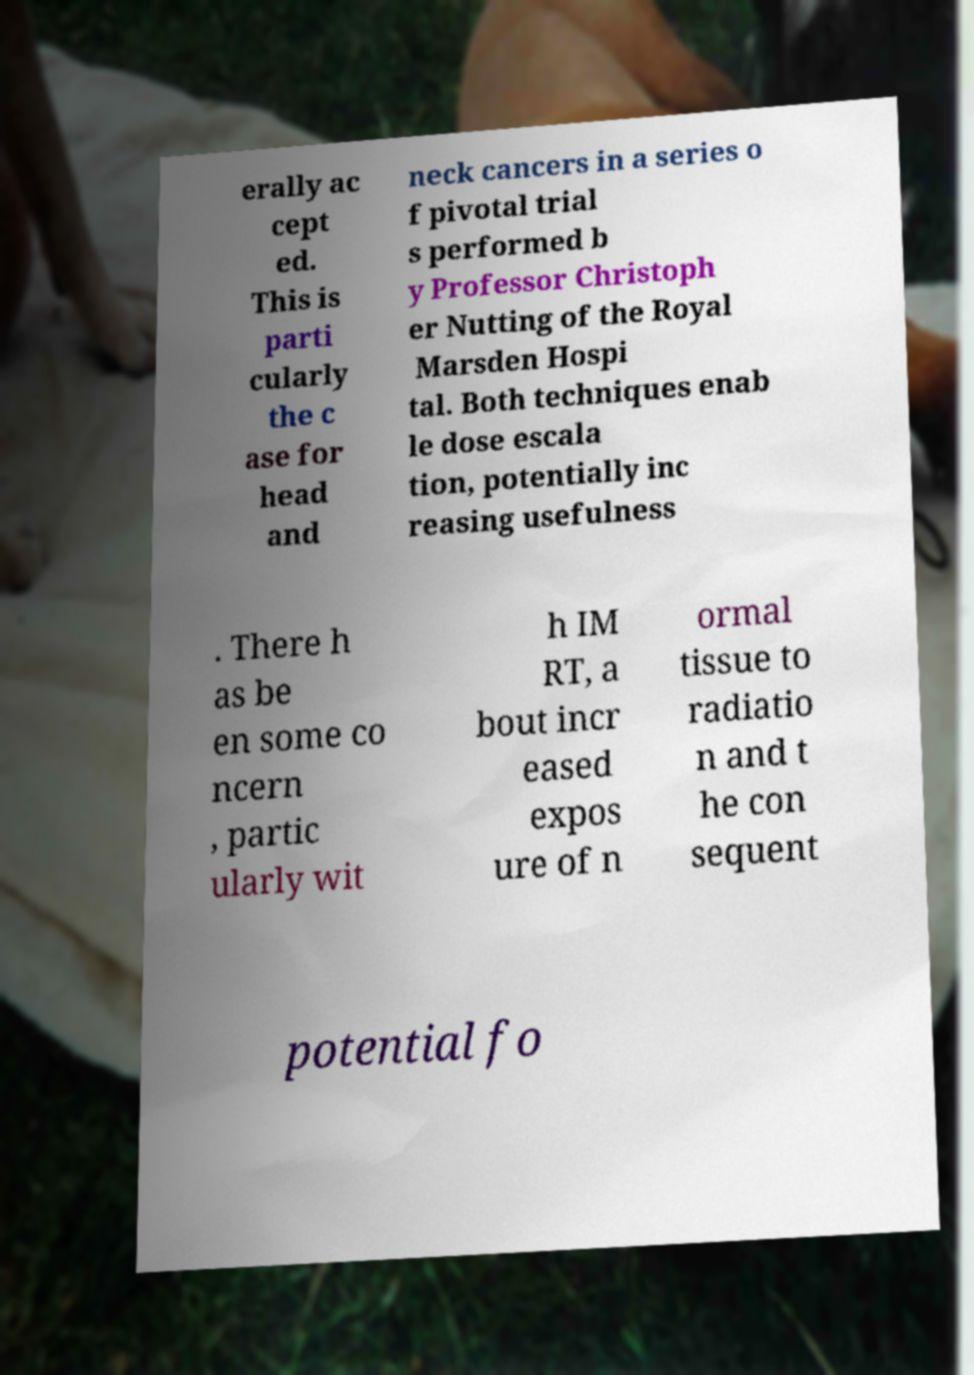I need the written content from this picture converted into text. Can you do that? erally ac cept ed. This is parti cularly the c ase for head and neck cancers in a series o f pivotal trial s performed b y Professor Christoph er Nutting of the Royal Marsden Hospi tal. Both techniques enab le dose escala tion, potentially inc reasing usefulness . There h as be en some co ncern , partic ularly wit h IM RT, a bout incr eased expos ure of n ormal tissue to radiatio n and t he con sequent potential fo 